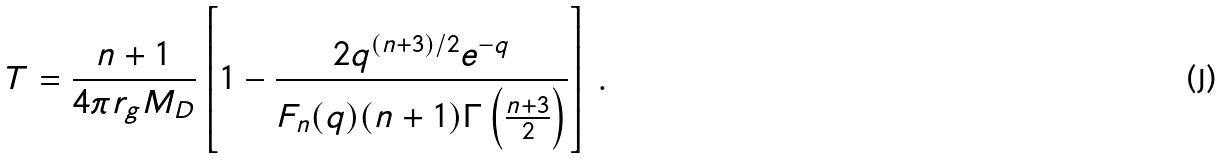<formula> <loc_0><loc_0><loc_500><loc_500>T = \frac { n + 1 } { 4 \pi r _ { g } M _ { D } } \left [ 1 - \frac { 2 q ^ { ( n + 3 ) / 2 } e ^ { - q } } { F _ { n } ( q ) ( n + 1 ) \Gamma \left ( \frac { n + 3 } { 2 } \right ) } \right ] \, .</formula> 